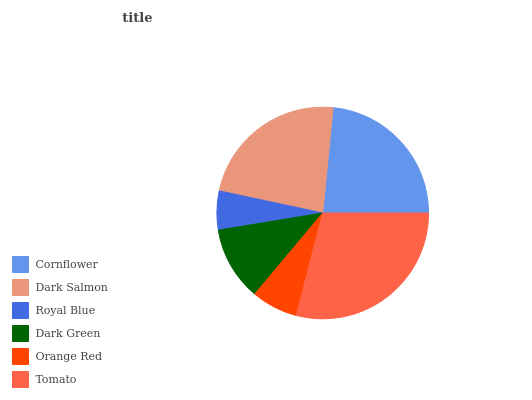Is Royal Blue the minimum?
Answer yes or no. Yes. Is Tomato the maximum?
Answer yes or no. Yes. Is Dark Salmon the minimum?
Answer yes or no. No. Is Dark Salmon the maximum?
Answer yes or no. No. Is Cornflower greater than Dark Salmon?
Answer yes or no. Yes. Is Dark Salmon less than Cornflower?
Answer yes or no. Yes. Is Dark Salmon greater than Cornflower?
Answer yes or no. No. Is Cornflower less than Dark Salmon?
Answer yes or no. No. Is Dark Salmon the high median?
Answer yes or no. Yes. Is Dark Green the low median?
Answer yes or no. Yes. Is Orange Red the high median?
Answer yes or no. No. Is Cornflower the low median?
Answer yes or no. No. 